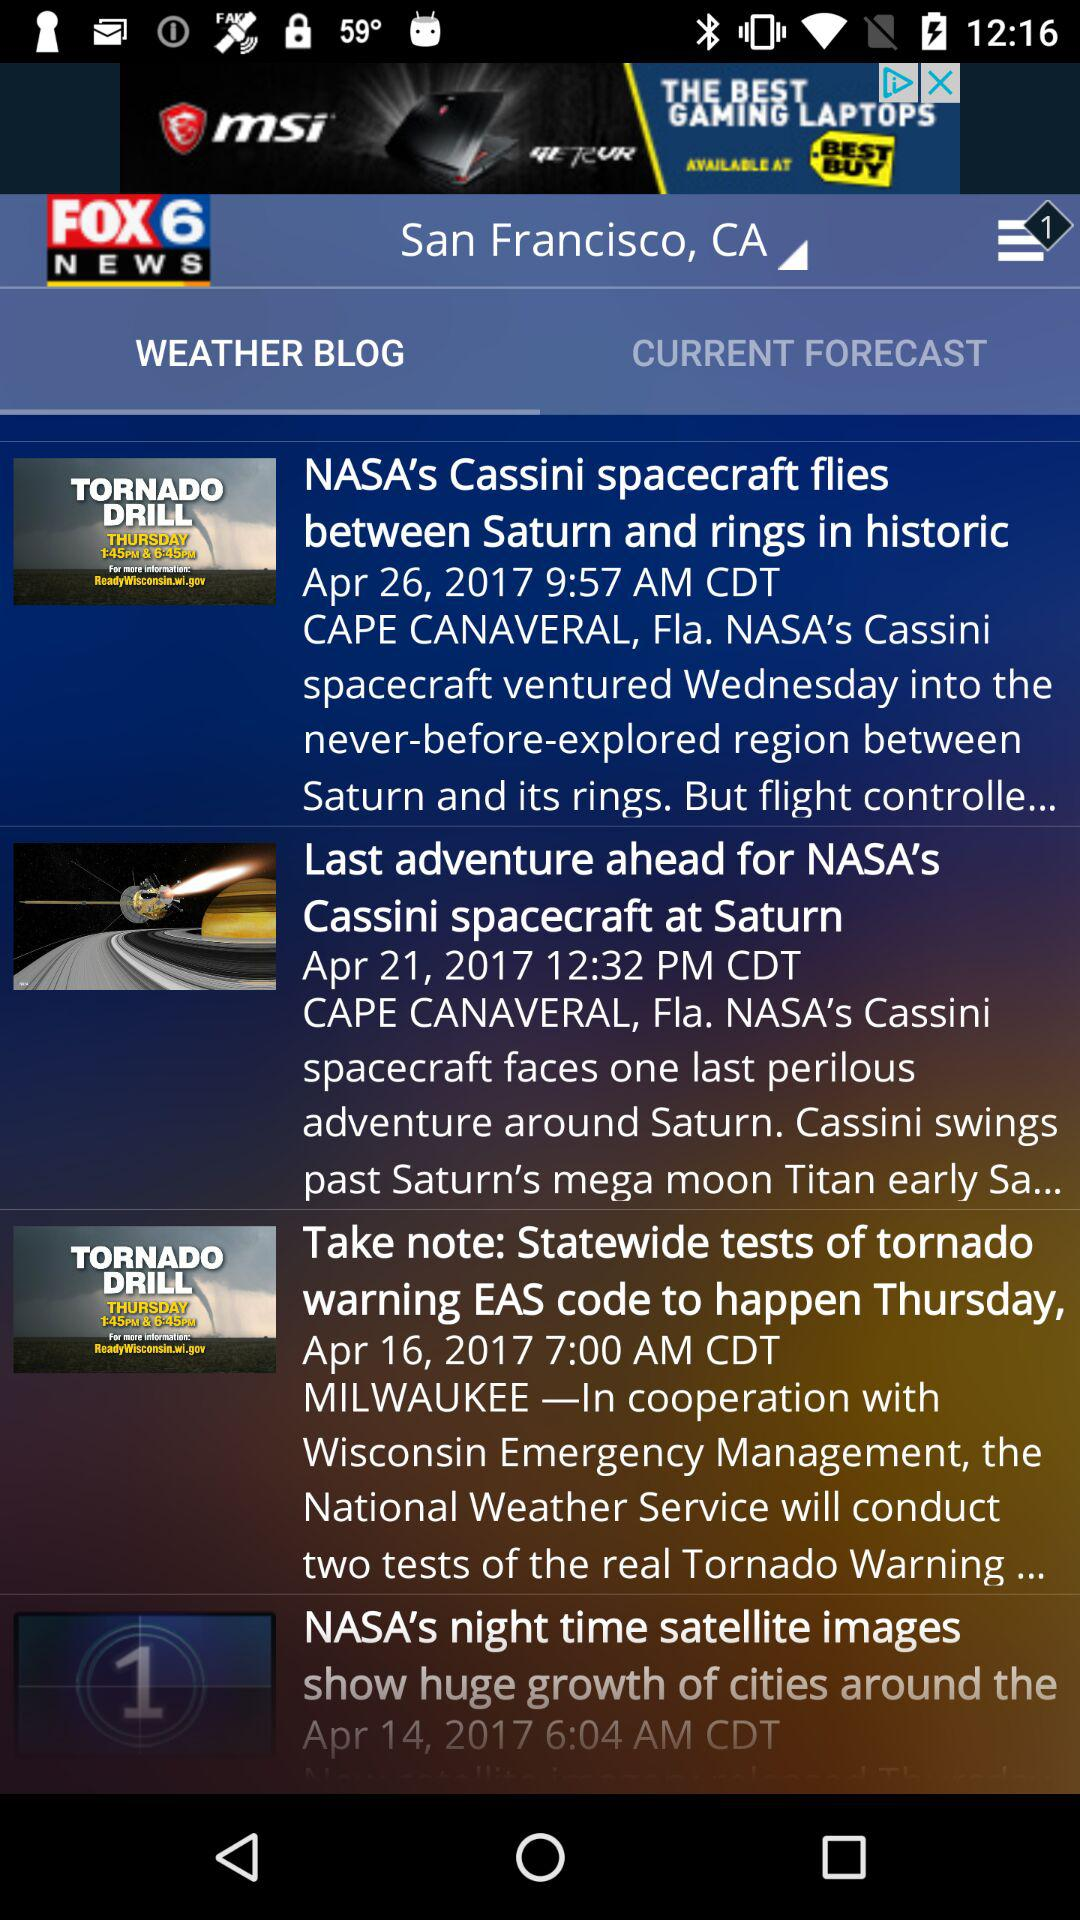How many more days are there between the latest and oldest article dates?
Answer the question using a single word or phrase. 12 